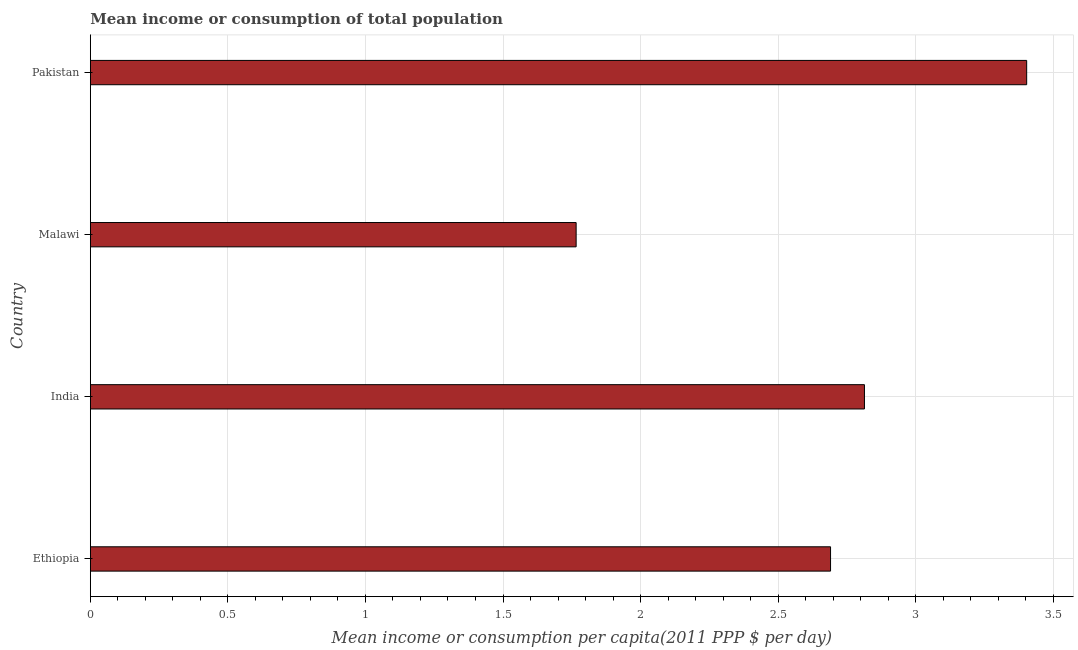What is the title of the graph?
Your answer should be very brief. Mean income or consumption of total population. What is the label or title of the X-axis?
Your answer should be very brief. Mean income or consumption per capita(2011 PPP $ per day). What is the mean income or consumption in Malawi?
Keep it short and to the point. 1.77. Across all countries, what is the maximum mean income or consumption?
Provide a short and direct response. 3.4. Across all countries, what is the minimum mean income or consumption?
Give a very brief answer. 1.77. In which country was the mean income or consumption minimum?
Your response must be concise. Malawi. What is the sum of the mean income or consumption?
Offer a terse response. 10.67. What is the difference between the mean income or consumption in Malawi and Pakistan?
Ensure brevity in your answer.  -1.64. What is the average mean income or consumption per country?
Your response must be concise. 2.67. What is the median mean income or consumption?
Your answer should be compact. 2.75. What is the ratio of the mean income or consumption in Ethiopia to that in Malawi?
Keep it short and to the point. 1.52. What is the difference between the highest and the second highest mean income or consumption?
Ensure brevity in your answer.  0.59. What is the difference between the highest and the lowest mean income or consumption?
Your answer should be compact. 1.64. How many bars are there?
Your answer should be very brief. 4. What is the Mean income or consumption per capita(2011 PPP $ per day) in Ethiopia?
Keep it short and to the point. 2.69. What is the Mean income or consumption per capita(2011 PPP $ per day) of India?
Offer a very short reply. 2.81. What is the Mean income or consumption per capita(2011 PPP $ per day) of Malawi?
Your answer should be very brief. 1.77. What is the Mean income or consumption per capita(2011 PPP $ per day) of Pakistan?
Your answer should be compact. 3.4. What is the difference between the Mean income or consumption per capita(2011 PPP $ per day) in Ethiopia and India?
Your response must be concise. -0.12. What is the difference between the Mean income or consumption per capita(2011 PPP $ per day) in Ethiopia and Malawi?
Offer a terse response. 0.92. What is the difference between the Mean income or consumption per capita(2011 PPP $ per day) in Ethiopia and Pakistan?
Keep it short and to the point. -0.71. What is the difference between the Mean income or consumption per capita(2011 PPP $ per day) in India and Malawi?
Give a very brief answer. 1.05. What is the difference between the Mean income or consumption per capita(2011 PPP $ per day) in India and Pakistan?
Give a very brief answer. -0.59. What is the difference between the Mean income or consumption per capita(2011 PPP $ per day) in Malawi and Pakistan?
Provide a short and direct response. -1.64. What is the ratio of the Mean income or consumption per capita(2011 PPP $ per day) in Ethiopia to that in India?
Provide a succinct answer. 0.96. What is the ratio of the Mean income or consumption per capita(2011 PPP $ per day) in Ethiopia to that in Malawi?
Provide a short and direct response. 1.52. What is the ratio of the Mean income or consumption per capita(2011 PPP $ per day) in Ethiopia to that in Pakistan?
Ensure brevity in your answer.  0.79. What is the ratio of the Mean income or consumption per capita(2011 PPP $ per day) in India to that in Malawi?
Ensure brevity in your answer.  1.59. What is the ratio of the Mean income or consumption per capita(2011 PPP $ per day) in India to that in Pakistan?
Your answer should be compact. 0.83. What is the ratio of the Mean income or consumption per capita(2011 PPP $ per day) in Malawi to that in Pakistan?
Your answer should be very brief. 0.52. 